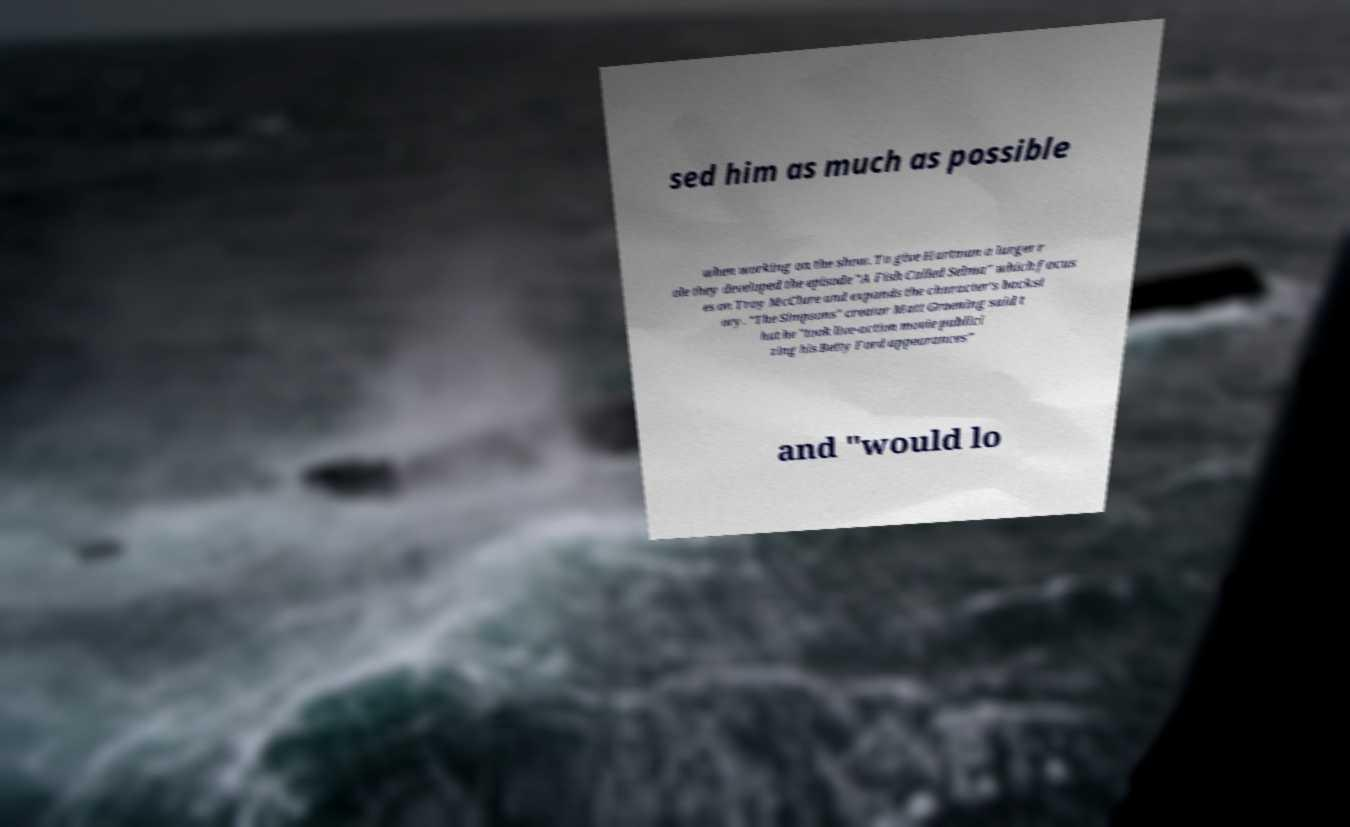What messages or text are displayed in this image? I need them in a readable, typed format. sed him as much as possible when working on the show. To give Hartman a larger r ole they developed the episode "A Fish Called Selma" which focus es on Troy McClure and expands the character's backst ory. "The Simpsons" creator Matt Groening said t hat he "took live-action movie publici zing his Betty Ford appearances" and "would lo 